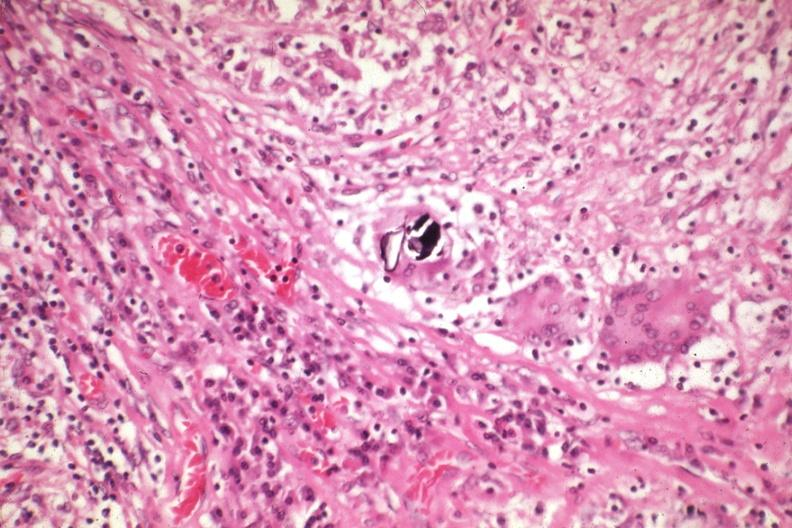s endometritis postpartum present?
Answer the question using a single word or phrase. No 